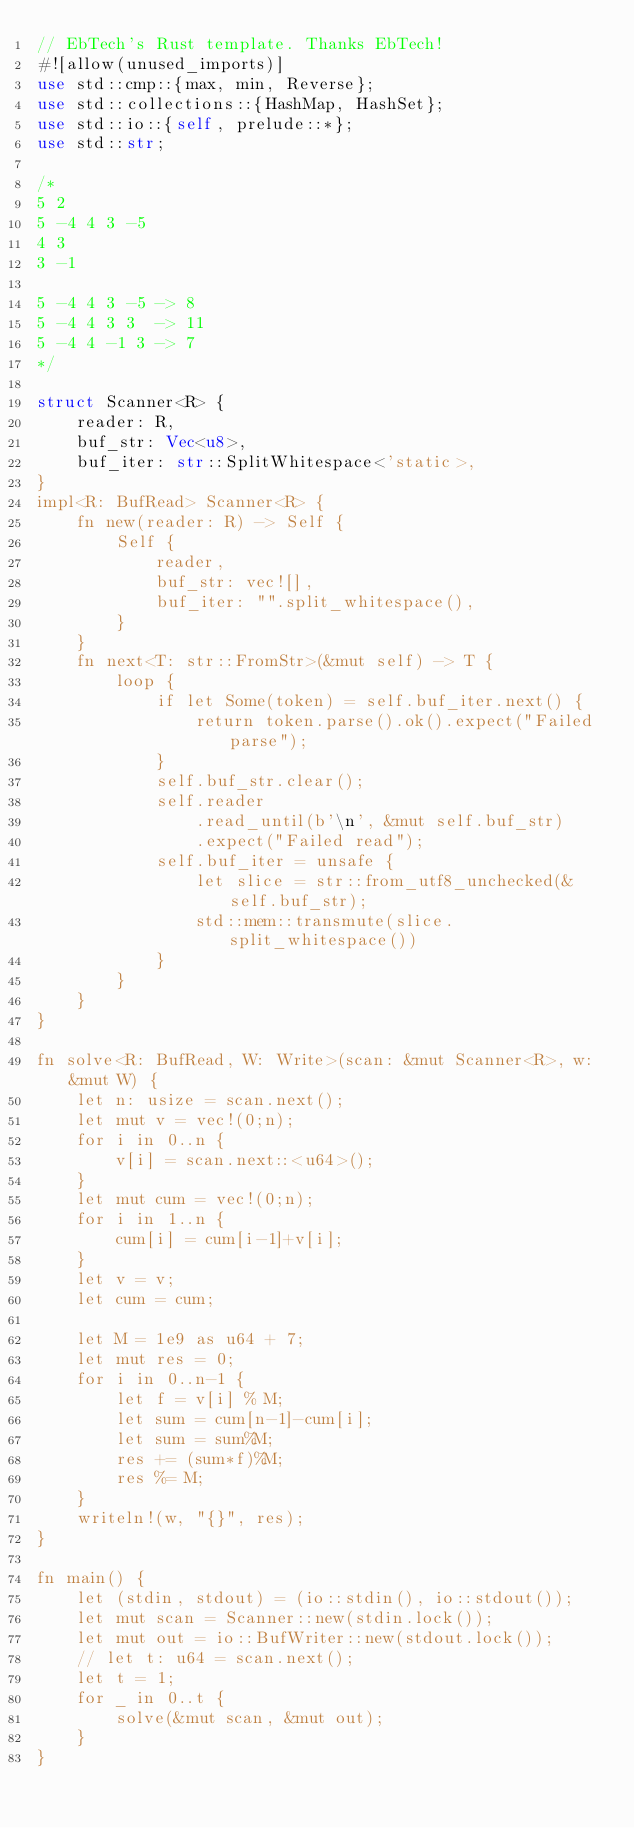<code> <loc_0><loc_0><loc_500><loc_500><_Rust_>// EbTech's Rust template. Thanks EbTech!
#![allow(unused_imports)]
use std::cmp::{max, min, Reverse};
use std::collections::{HashMap, HashSet};
use std::io::{self, prelude::*};
use std::str;

/*
5 2
5 -4 4 3 -5
4 3
3 -1

5 -4 4 3 -5 -> 8
5 -4 4 3 3  -> 11
5 -4 4 -1 3 -> 7
*/

struct Scanner<R> {
    reader: R,
    buf_str: Vec<u8>,
    buf_iter: str::SplitWhitespace<'static>,
}
impl<R: BufRead> Scanner<R> {
    fn new(reader: R) -> Self {
        Self {
            reader,
            buf_str: vec![],
            buf_iter: "".split_whitespace(),
        }
    }
    fn next<T: str::FromStr>(&mut self) -> T {
        loop {
            if let Some(token) = self.buf_iter.next() {
                return token.parse().ok().expect("Failed parse");
            }
            self.buf_str.clear();
            self.reader
                .read_until(b'\n', &mut self.buf_str)
                .expect("Failed read");
            self.buf_iter = unsafe {
                let slice = str::from_utf8_unchecked(&self.buf_str);
                std::mem::transmute(slice.split_whitespace())
            }
        }
    }
}

fn solve<R: BufRead, W: Write>(scan: &mut Scanner<R>, w: &mut W) {
    let n: usize = scan.next();
    let mut v = vec!(0;n);
    for i in 0..n {
        v[i] = scan.next::<u64>();
    }
    let mut cum = vec!(0;n);
    for i in 1..n {
        cum[i] = cum[i-1]+v[i];
    }
    let v = v;
    let cum = cum;

    let M = 1e9 as u64 + 7;
    let mut res = 0;
    for i in 0..n-1 {
        let f = v[i] % M;
        let sum = cum[n-1]-cum[i];
        let sum = sum%M;
        res += (sum*f)%M;
        res %= M;
    }
    writeln!(w, "{}", res);
}

fn main() {
    let (stdin, stdout) = (io::stdin(), io::stdout());
    let mut scan = Scanner::new(stdin.lock());
    let mut out = io::BufWriter::new(stdout.lock());
    // let t: u64 = scan.next();
    let t = 1;
    for _ in 0..t {
        solve(&mut scan, &mut out);
    }
}
</code> 